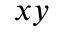<formula> <loc_0><loc_0><loc_500><loc_500>x y</formula> 